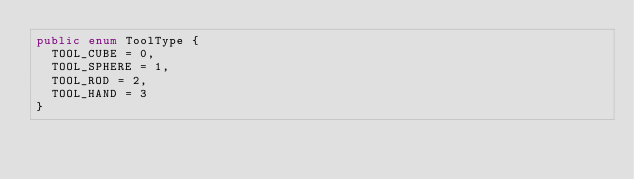Convert code to text. <code><loc_0><loc_0><loc_500><loc_500><_C#_>public enum ToolType {
	TOOL_CUBE = 0, 
	TOOL_SPHERE = 1, 
	TOOL_ROD = 2, 
	TOOL_HAND = 3
}
</code> 